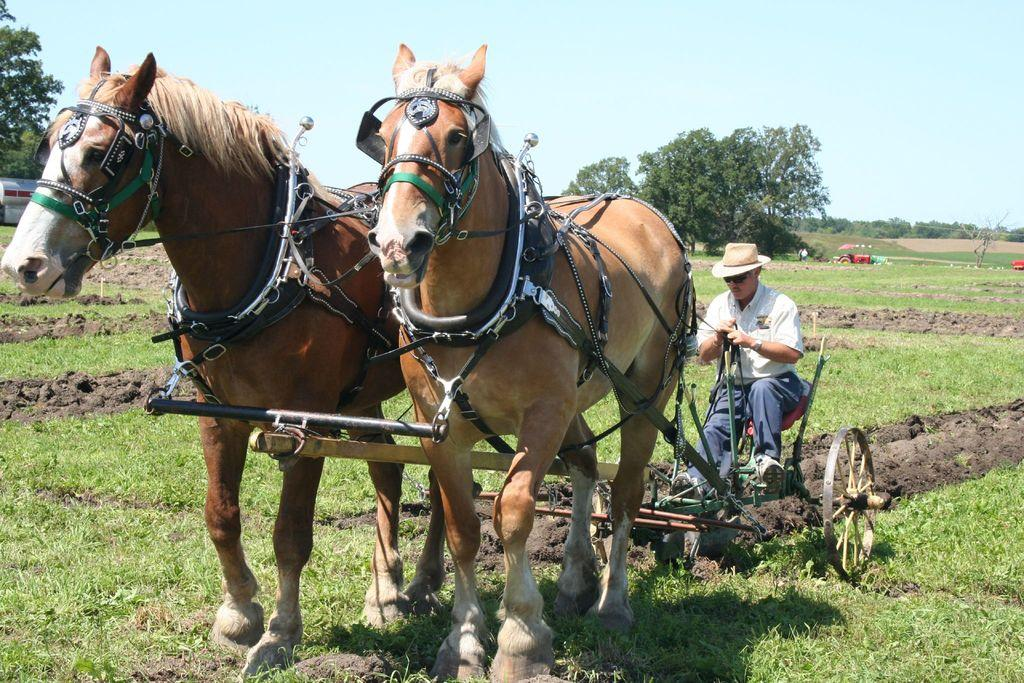What is the man in the image doing? The man is riding a horse cart in the image. What type of terrain can be seen in the image? There is a grass field visible in the image. What other types of transportation are present in the image? There are vehicles in the image. What can be seen in the background of the image? Trees are present in the image. How would you describe the weather in the image? The sky is visible in the image and appears cloudy. What type of religious ceremony is taking place in the image? There is no indication of a religious ceremony in the image; it features a man riding a horse cart, vehicles, trees, and a cloudy sky. 